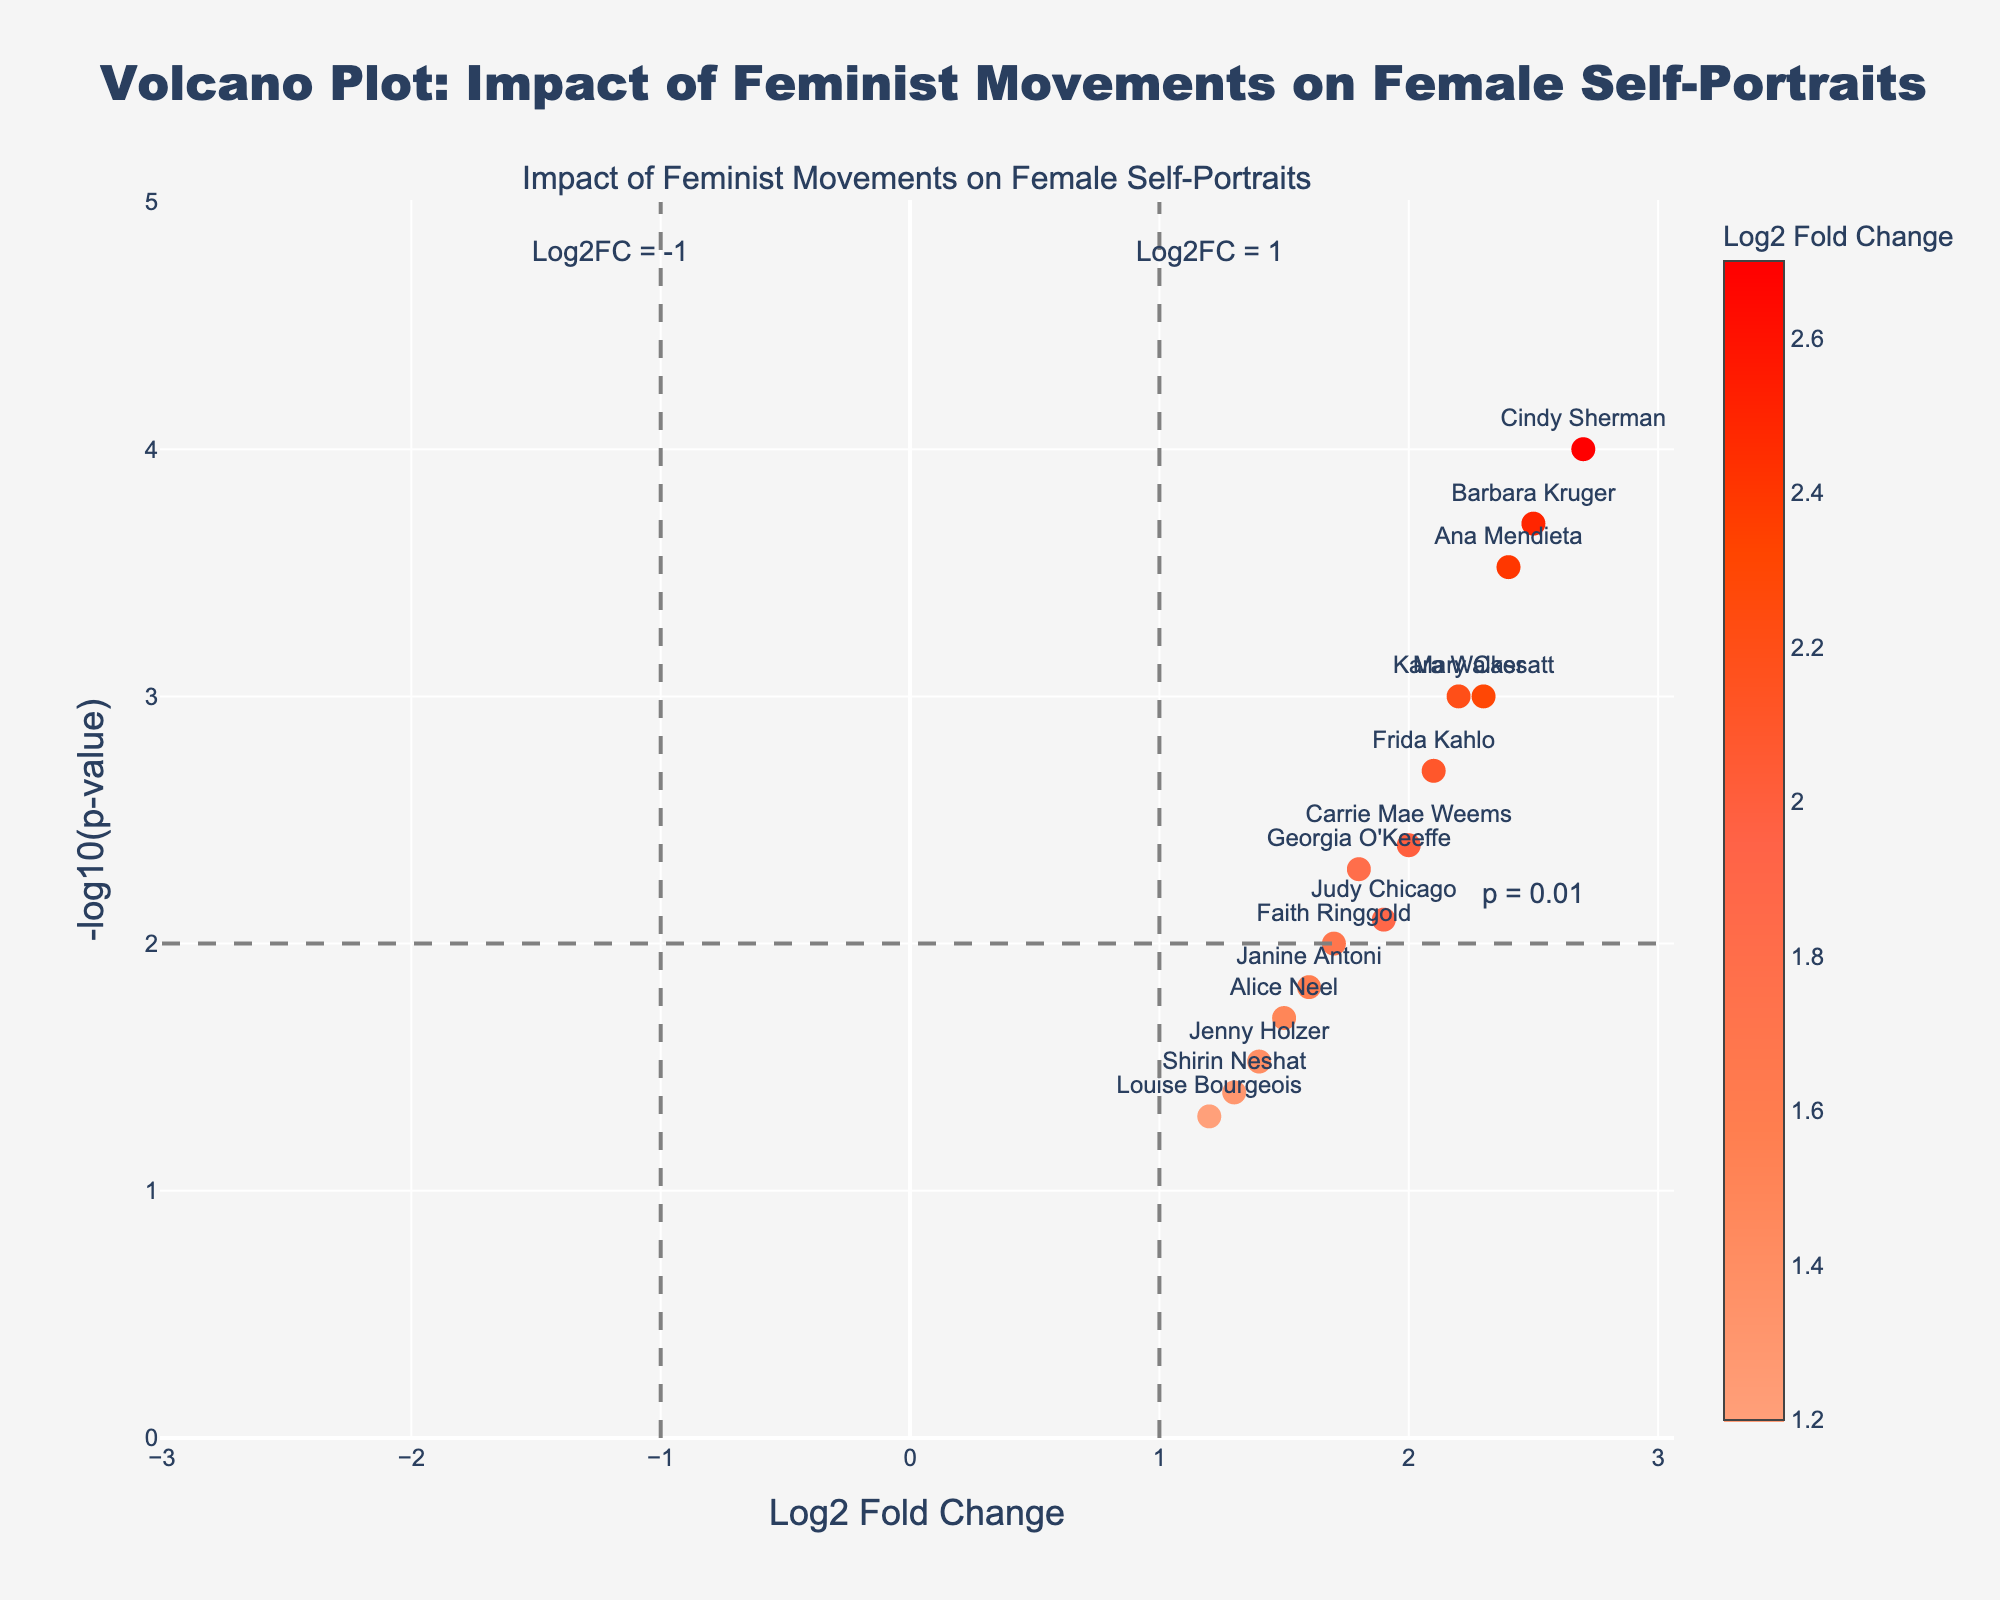Which artist has the highest log2 fold change? The artist with the highest log2 fold change is identified by looking for the highest value on the x-axis (log2 fold change). Cindy Sherman is the artist with a log2 fold change of 2.7.
Answer: Cindy Sherman Which artist has the lowest p-value? The artist with the lowest p-value can be found by looking for the highest point on the y-axis (-log10(p-value)), as a lower p-value corresponds to a higher -log10(p-value). Cindy Sherman has the lowest p-value (highest -log10(p-value)).
Answer: Cindy Sherman What are the axes labels in the plot? The labels on the x-axis and y-axis provide information about the plotted data. The x-axis is labeled "Log2 Fold Change," and the y-axis is labeled "-log10(p-value)".
Answer: Log2 Fold Change, -log10(p-value) How many artists have a log2 fold change greater than 2? By looking at the x-axis (log2 fold change) and counting data points to the right of the value 2, there are 6 artists: Mary Cassatt, Frida Kahlo, Cindy Sherman, Ana Mendieta, Kara Walker, and Barbara Kruger.
Answer: 6 Which artist is closest to the significance threshold line of p = 0.01? The p-value threshold line for p = 0.01 is represented by a horizontal line at y = 2. The artist closest to this line (without being above it) is Alice Neel, whose point is just slightly above the line.
Answer: Alice Neel How many artists have both a log2 fold change greater than 1 and a p-value less than 0.01? By examining points that are to the right of the vertical line at x = 1 and above the horizontal line at y = 2, there are 8 artists: Mary Cassatt, Georgia O'Keeffe, Frida Kahlo, Cindy Sherman, Ana Mendieta, Kara Walker, Barbara Kruger, Carrie Mae Weems.
Answer: 8 What is the significance and interpretation of the markers' color? The markers' color represents the log2 fold change value, with a custom color scale indicating different intensities where darker colors represent higher values. This helps to visually distinguish between artists based on the magnitude of change in the frequency of female self-portraits.
Answer: Signifies log2 fold change Compare the log2 fold change values for Mary Cassatt and Louise Bourgeois. Mary Cassatt's log2 fold change value is 2.3, while Louise Bourgeois' is 1.2. Therefore, Mary Cassatt has a higher log2 fold change value compared to Louise Bourgeois.
Answer: Mary Cassatt's value is higher Are there any artists with a negative log2 fold change? By inspecting the x-axis (log2 fold change) for any points on the left side of zero, there are no artists with negative log2 fold changes in the plot. All points are to the right of zero, indicating positive changes.
Answer: No 